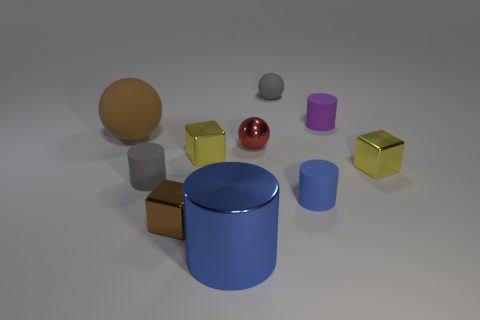Considering the positions of the objects, what might this arrangement suggest about their use? The spread-out arrangement with adequate space between each object suggests a display or a composition for visual assessment, emphasizing the variety in shapes, sizes, and colors. Could there be an artistic purpose behind this selection of objects? Certainly, the collection of objects with differing textures, reflections, and colors could serve an artistic aim to showcase contrasts, perhaps in an educational setting or as part of a visual study in design. 